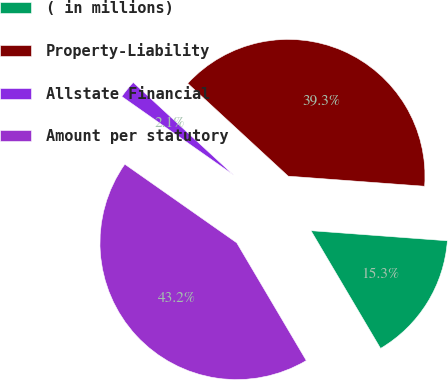<chart> <loc_0><loc_0><loc_500><loc_500><pie_chart><fcel>( in millions)<fcel>Property-Liability<fcel>Allstate Financial<fcel>Amount per statutory<nl><fcel>15.33%<fcel>39.31%<fcel>2.12%<fcel>43.24%<nl></chart> 